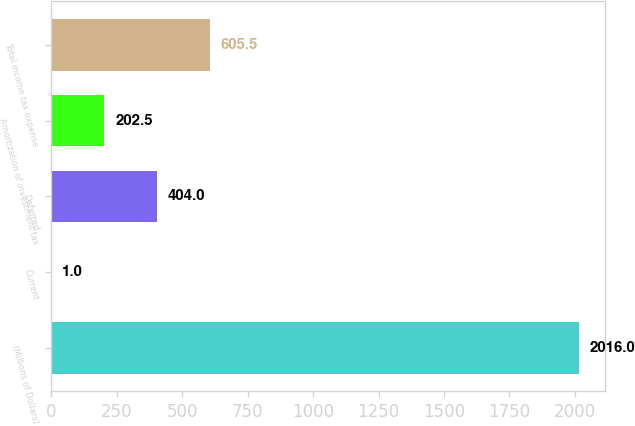<chart> <loc_0><loc_0><loc_500><loc_500><bar_chart><fcel>(Millions of Dollars)<fcel>Current<fcel>Deferred<fcel>Amortization of investment tax<fcel>Total income tax expense<nl><fcel>2016<fcel>1<fcel>404<fcel>202.5<fcel>605.5<nl></chart> 